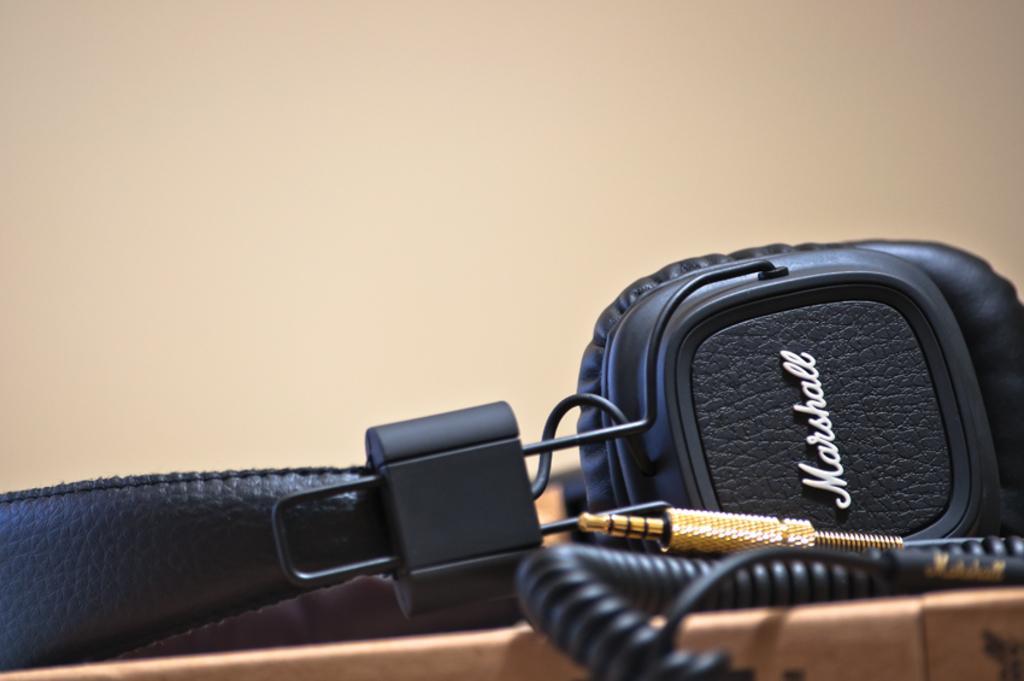Can you describe this image briefly? In this image there is some object in the box. In the background of the image there is a wall. 